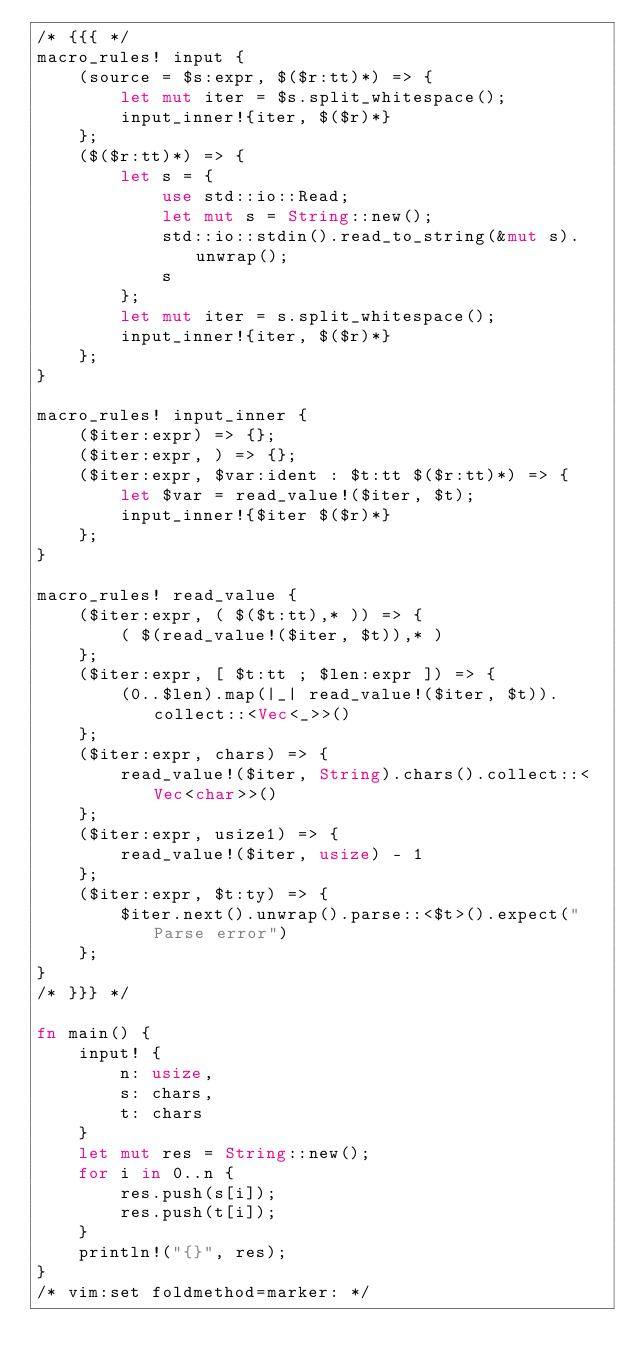<code> <loc_0><loc_0><loc_500><loc_500><_Rust_>/* {{{ */
macro_rules! input {
    (source = $s:expr, $($r:tt)*) => {
        let mut iter = $s.split_whitespace();
        input_inner!{iter, $($r)*}
    };
    ($($r:tt)*) => {
        let s = {
            use std::io::Read;
            let mut s = String::new();
            std::io::stdin().read_to_string(&mut s).unwrap();
            s
        };
        let mut iter = s.split_whitespace();
        input_inner!{iter, $($r)*}
    };
}

macro_rules! input_inner {
    ($iter:expr) => {};
    ($iter:expr, ) => {};
    ($iter:expr, $var:ident : $t:tt $($r:tt)*) => {
        let $var = read_value!($iter, $t);
        input_inner!{$iter $($r)*}
    };
}

macro_rules! read_value {
    ($iter:expr, ( $($t:tt),* )) => {
        ( $(read_value!($iter, $t)),* )
    };
    ($iter:expr, [ $t:tt ; $len:expr ]) => {
        (0..$len).map(|_| read_value!($iter, $t)).collect::<Vec<_>>()
    };
    ($iter:expr, chars) => {
        read_value!($iter, String).chars().collect::<Vec<char>>()
    };
    ($iter:expr, usize1) => {
        read_value!($iter, usize) - 1
    };
    ($iter:expr, $t:ty) => {
        $iter.next().unwrap().parse::<$t>().expect("Parse error")
    };
}
/* }}} */

fn main() {
    input! {
        n: usize,
        s: chars,
        t: chars
    }
    let mut res = String::new();
    for i in 0..n {
        res.push(s[i]);
        res.push(t[i]);
    }
    println!("{}", res);
}
/* vim:set foldmethod=marker: */
</code> 